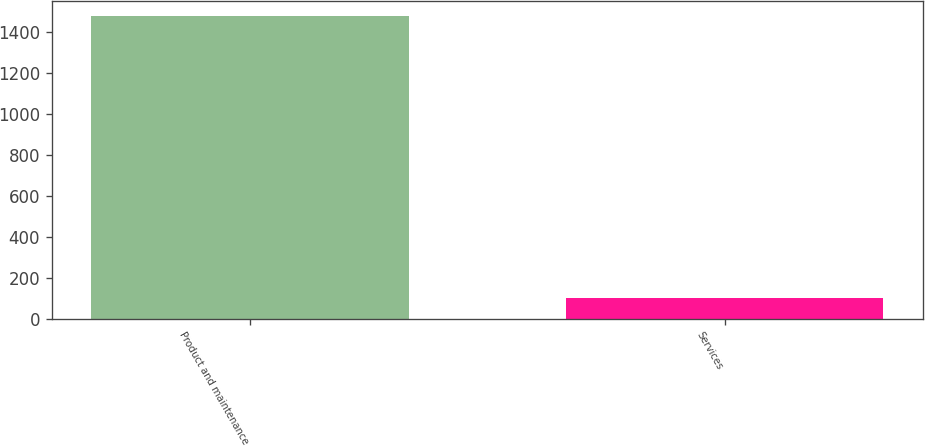Convert chart. <chart><loc_0><loc_0><loc_500><loc_500><bar_chart><fcel>Product and maintenance<fcel>Services<nl><fcel>1479.2<fcel>101.8<nl></chart> 